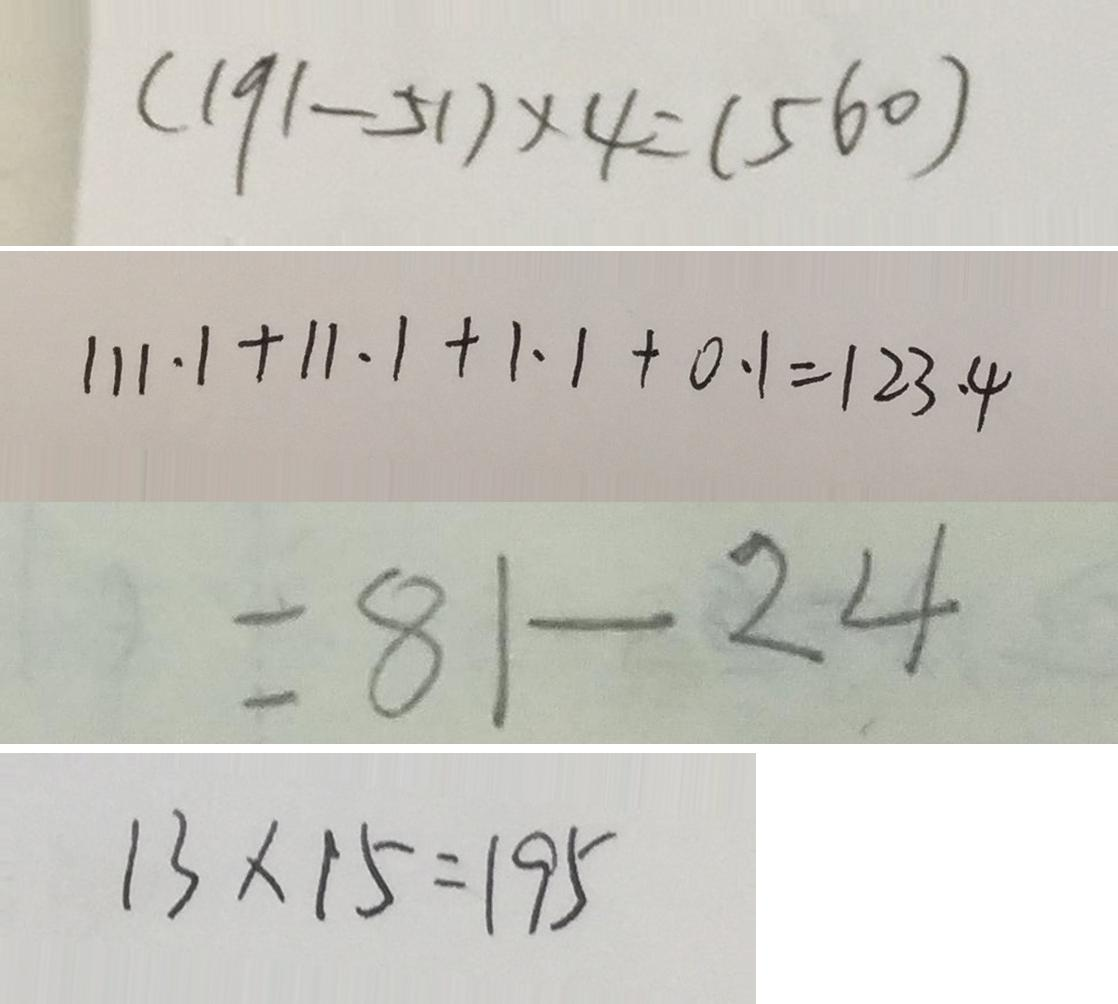<formula> <loc_0><loc_0><loc_500><loc_500>( 1 9 1 - 5 1 ) \times 4 = ( 5 6 0 ) 
 1 1 1 . 1 + 1 1 . 1 + 1 . 1 + 0 . 1 = 1 2 3 . 4 
 = 8 1 - 2 4 
 1 3 \times 1 5 = 1 9 5</formula> 